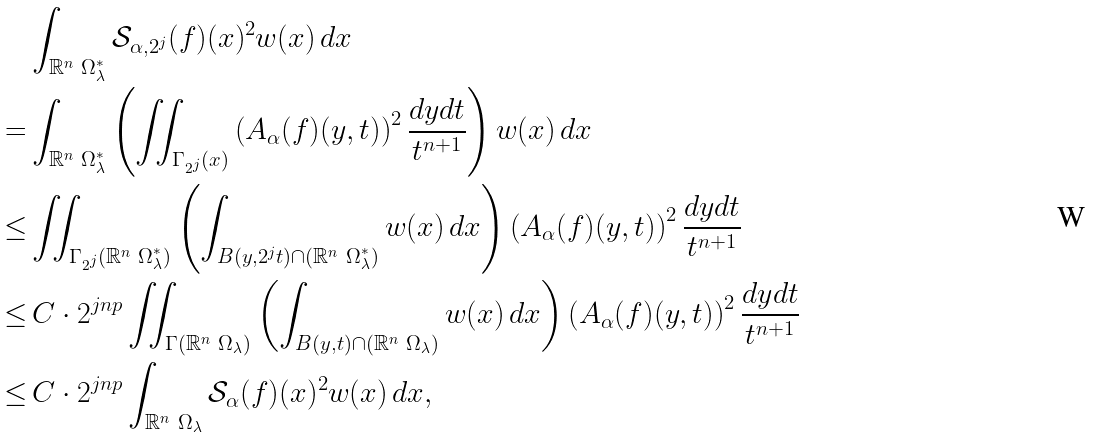Convert formula to latex. <formula><loc_0><loc_0><loc_500><loc_500>& \int _ { \mathbb { R } ^ { n } \ \Omega ^ { * } _ { \lambda } } \mathcal { S } _ { \alpha , 2 ^ { j } } ( f ) ( x ) ^ { 2 } w ( x ) \, d x \\ = & \int _ { \mathbb { R } ^ { n } \ \Omega ^ { * } _ { \lambda } } \left ( \iint _ { \Gamma _ { 2 ^ { j } } ( x ) } \left ( A _ { \alpha } ( f ) ( y , t ) \right ) ^ { 2 } \frac { d y d t } { t ^ { n + 1 } } \right ) w ( x ) \, d x \\ \leq & \iint _ { \Gamma _ { 2 ^ { j } } ( \mathbb { R } ^ { n } \ \Omega ^ { * } _ { \lambda } ) } \left ( \int _ { B ( y , 2 ^ { j } t ) \cap ( \mathbb { R } ^ { n } \ \Omega _ { \lambda } ^ { * } ) } w ( x ) \, d x \right ) \left ( A _ { \alpha } ( f ) ( y , t ) \right ) ^ { 2 } \frac { d y d t } { t ^ { n + 1 } } \\ \leq & \, C \cdot 2 ^ { j n p } \iint _ { \Gamma ( \mathbb { R } ^ { n } \ \Omega _ { \lambda } ) } \left ( \int _ { B ( y , t ) \cap ( \mathbb { R } ^ { n } \ \Omega _ { \lambda } ) } w ( x ) \, d x \right ) \left ( A _ { \alpha } ( f ) ( y , t ) \right ) ^ { 2 } \frac { d y d t } { t ^ { n + 1 } } \\ \leq & \, C \cdot 2 ^ { j n p } \int _ { \mathbb { R } ^ { n } \ \Omega _ { \lambda } } \mathcal { S } _ { \alpha } ( f ) ( x ) ^ { 2 } w ( x ) \, d x ,</formula> 